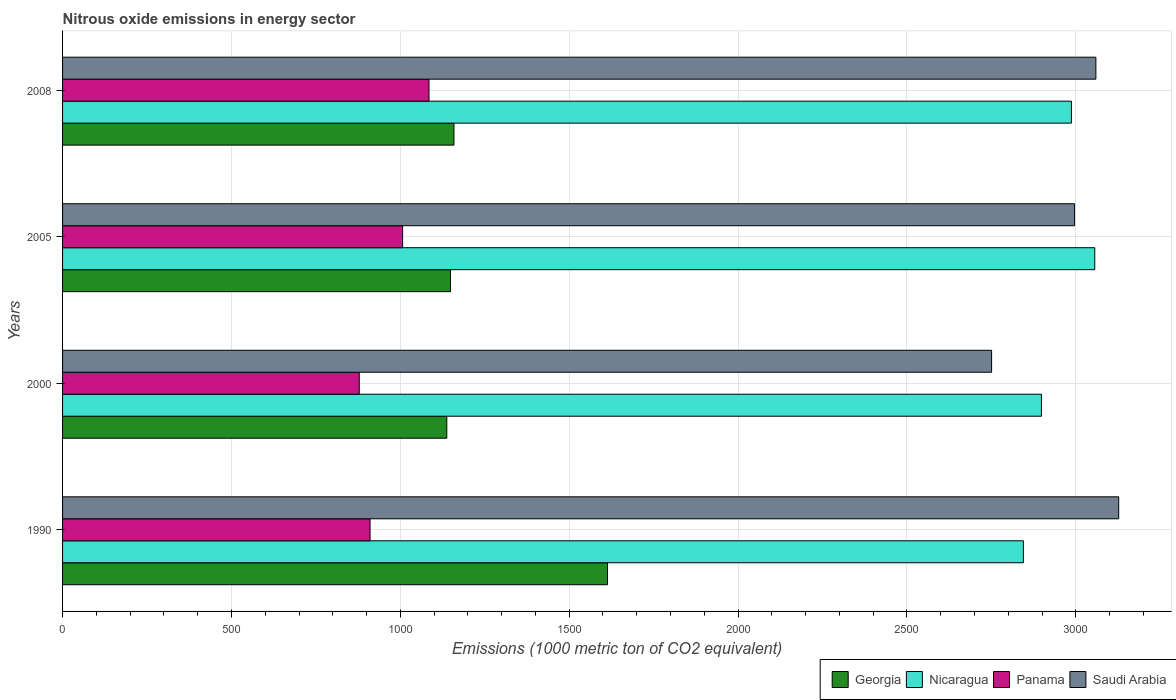How many groups of bars are there?
Provide a succinct answer. 4. Are the number of bars per tick equal to the number of legend labels?
Provide a short and direct response. Yes. What is the amount of nitrous oxide emitted in Panama in 2008?
Ensure brevity in your answer.  1084.9. Across all years, what is the maximum amount of nitrous oxide emitted in Nicaragua?
Ensure brevity in your answer.  3056.1. Across all years, what is the minimum amount of nitrous oxide emitted in Panama?
Your answer should be very brief. 878.4. In which year was the amount of nitrous oxide emitted in Panama minimum?
Keep it short and to the point. 2000. What is the total amount of nitrous oxide emitted in Nicaragua in the graph?
Offer a very short reply. 1.18e+04. What is the difference between the amount of nitrous oxide emitted in Saudi Arabia in 1990 and that in 2008?
Ensure brevity in your answer.  67.5. What is the difference between the amount of nitrous oxide emitted in Panama in 2000 and the amount of nitrous oxide emitted in Nicaragua in 2008?
Provide a succinct answer. -2108.5. What is the average amount of nitrous oxide emitted in Nicaragua per year?
Provide a succinct answer. 2946.47. In the year 2000, what is the difference between the amount of nitrous oxide emitted in Saudi Arabia and amount of nitrous oxide emitted in Georgia?
Keep it short and to the point. 1613. What is the ratio of the amount of nitrous oxide emitted in Saudi Arabia in 2000 to that in 2005?
Your answer should be compact. 0.92. What is the difference between the highest and the second highest amount of nitrous oxide emitted in Georgia?
Ensure brevity in your answer.  454.6. What is the difference between the highest and the lowest amount of nitrous oxide emitted in Nicaragua?
Make the answer very short. 211.4. Is the sum of the amount of nitrous oxide emitted in Nicaragua in 2000 and 2005 greater than the maximum amount of nitrous oxide emitted in Georgia across all years?
Your response must be concise. Yes. Is it the case that in every year, the sum of the amount of nitrous oxide emitted in Nicaragua and amount of nitrous oxide emitted in Saudi Arabia is greater than the sum of amount of nitrous oxide emitted in Panama and amount of nitrous oxide emitted in Georgia?
Provide a succinct answer. Yes. What does the 2nd bar from the top in 1990 represents?
Provide a succinct answer. Panama. What does the 3rd bar from the bottom in 1990 represents?
Your answer should be compact. Panama. Are all the bars in the graph horizontal?
Provide a short and direct response. Yes. How many years are there in the graph?
Give a very brief answer. 4. Does the graph contain any zero values?
Offer a very short reply. No. Does the graph contain grids?
Give a very brief answer. Yes. Where does the legend appear in the graph?
Your answer should be very brief. Bottom right. How are the legend labels stacked?
Your answer should be very brief. Horizontal. What is the title of the graph?
Give a very brief answer. Nitrous oxide emissions in energy sector. Does "Ukraine" appear as one of the legend labels in the graph?
Provide a short and direct response. No. What is the label or title of the X-axis?
Ensure brevity in your answer.  Emissions (1000 metric ton of CO2 equivalent). What is the label or title of the Y-axis?
Make the answer very short. Years. What is the Emissions (1000 metric ton of CO2 equivalent) in Georgia in 1990?
Offer a terse response. 1613.4. What is the Emissions (1000 metric ton of CO2 equivalent) of Nicaragua in 1990?
Your answer should be very brief. 2844.7. What is the Emissions (1000 metric ton of CO2 equivalent) of Panama in 1990?
Your response must be concise. 910.4. What is the Emissions (1000 metric ton of CO2 equivalent) of Saudi Arabia in 1990?
Your answer should be very brief. 3126.9. What is the Emissions (1000 metric ton of CO2 equivalent) in Georgia in 2000?
Provide a succinct answer. 1137.6. What is the Emissions (1000 metric ton of CO2 equivalent) of Nicaragua in 2000?
Provide a short and direct response. 2898.2. What is the Emissions (1000 metric ton of CO2 equivalent) in Panama in 2000?
Offer a very short reply. 878.4. What is the Emissions (1000 metric ton of CO2 equivalent) of Saudi Arabia in 2000?
Ensure brevity in your answer.  2750.6. What is the Emissions (1000 metric ton of CO2 equivalent) of Georgia in 2005?
Make the answer very short. 1148.6. What is the Emissions (1000 metric ton of CO2 equivalent) of Nicaragua in 2005?
Offer a terse response. 3056.1. What is the Emissions (1000 metric ton of CO2 equivalent) in Panama in 2005?
Provide a succinct answer. 1006.8. What is the Emissions (1000 metric ton of CO2 equivalent) in Saudi Arabia in 2005?
Provide a succinct answer. 2996.3. What is the Emissions (1000 metric ton of CO2 equivalent) of Georgia in 2008?
Provide a short and direct response. 1158.8. What is the Emissions (1000 metric ton of CO2 equivalent) in Nicaragua in 2008?
Keep it short and to the point. 2986.9. What is the Emissions (1000 metric ton of CO2 equivalent) in Panama in 2008?
Ensure brevity in your answer.  1084.9. What is the Emissions (1000 metric ton of CO2 equivalent) of Saudi Arabia in 2008?
Offer a very short reply. 3059.4. Across all years, what is the maximum Emissions (1000 metric ton of CO2 equivalent) in Georgia?
Your response must be concise. 1613.4. Across all years, what is the maximum Emissions (1000 metric ton of CO2 equivalent) in Nicaragua?
Offer a very short reply. 3056.1. Across all years, what is the maximum Emissions (1000 metric ton of CO2 equivalent) of Panama?
Your response must be concise. 1084.9. Across all years, what is the maximum Emissions (1000 metric ton of CO2 equivalent) of Saudi Arabia?
Give a very brief answer. 3126.9. Across all years, what is the minimum Emissions (1000 metric ton of CO2 equivalent) of Georgia?
Your answer should be very brief. 1137.6. Across all years, what is the minimum Emissions (1000 metric ton of CO2 equivalent) in Nicaragua?
Offer a very short reply. 2844.7. Across all years, what is the minimum Emissions (1000 metric ton of CO2 equivalent) of Panama?
Offer a terse response. 878.4. Across all years, what is the minimum Emissions (1000 metric ton of CO2 equivalent) of Saudi Arabia?
Your answer should be compact. 2750.6. What is the total Emissions (1000 metric ton of CO2 equivalent) of Georgia in the graph?
Offer a very short reply. 5058.4. What is the total Emissions (1000 metric ton of CO2 equivalent) of Nicaragua in the graph?
Provide a short and direct response. 1.18e+04. What is the total Emissions (1000 metric ton of CO2 equivalent) of Panama in the graph?
Keep it short and to the point. 3880.5. What is the total Emissions (1000 metric ton of CO2 equivalent) of Saudi Arabia in the graph?
Give a very brief answer. 1.19e+04. What is the difference between the Emissions (1000 metric ton of CO2 equivalent) in Georgia in 1990 and that in 2000?
Your answer should be very brief. 475.8. What is the difference between the Emissions (1000 metric ton of CO2 equivalent) in Nicaragua in 1990 and that in 2000?
Keep it short and to the point. -53.5. What is the difference between the Emissions (1000 metric ton of CO2 equivalent) of Panama in 1990 and that in 2000?
Keep it short and to the point. 32. What is the difference between the Emissions (1000 metric ton of CO2 equivalent) in Saudi Arabia in 1990 and that in 2000?
Offer a very short reply. 376.3. What is the difference between the Emissions (1000 metric ton of CO2 equivalent) of Georgia in 1990 and that in 2005?
Keep it short and to the point. 464.8. What is the difference between the Emissions (1000 metric ton of CO2 equivalent) in Nicaragua in 1990 and that in 2005?
Provide a short and direct response. -211.4. What is the difference between the Emissions (1000 metric ton of CO2 equivalent) of Panama in 1990 and that in 2005?
Your answer should be compact. -96.4. What is the difference between the Emissions (1000 metric ton of CO2 equivalent) in Saudi Arabia in 1990 and that in 2005?
Make the answer very short. 130.6. What is the difference between the Emissions (1000 metric ton of CO2 equivalent) in Georgia in 1990 and that in 2008?
Provide a succinct answer. 454.6. What is the difference between the Emissions (1000 metric ton of CO2 equivalent) of Nicaragua in 1990 and that in 2008?
Ensure brevity in your answer.  -142.2. What is the difference between the Emissions (1000 metric ton of CO2 equivalent) in Panama in 1990 and that in 2008?
Your answer should be compact. -174.5. What is the difference between the Emissions (1000 metric ton of CO2 equivalent) of Saudi Arabia in 1990 and that in 2008?
Make the answer very short. 67.5. What is the difference between the Emissions (1000 metric ton of CO2 equivalent) of Georgia in 2000 and that in 2005?
Give a very brief answer. -11. What is the difference between the Emissions (1000 metric ton of CO2 equivalent) in Nicaragua in 2000 and that in 2005?
Provide a short and direct response. -157.9. What is the difference between the Emissions (1000 metric ton of CO2 equivalent) of Panama in 2000 and that in 2005?
Provide a short and direct response. -128.4. What is the difference between the Emissions (1000 metric ton of CO2 equivalent) of Saudi Arabia in 2000 and that in 2005?
Your answer should be compact. -245.7. What is the difference between the Emissions (1000 metric ton of CO2 equivalent) of Georgia in 2000 and that in 2008?
Give a very brief answer. -21.2. What is the difference between the Emissions (1000 metric ton of CO2 equivalent) of Nicaragua in 2000 and that in 2008?
Give a very brief answer. -88.7. What is the difference between the Emissions (1000 metric ton of CO2 equivalent) in Panama in 2000 and that in 2008?
Provide a succinct answer. -206.5. What is the difference between the Emissions (1000 metric ton of CO2 equivalent) in Saudi Arabia in 2000 and that in 2008?
Ensure brevity in your answer.  -308.8. What is the difference between the Emissions (1000 metric ton of CO2 equivalent) in Georgia in 2005 and that in 2008?
Offer a terse response. -10.2. What is the difference between the Emissions (1000 metric ton of CO2 equivalent) of Nicaragua in 2005 and that in 2008?
Make the answer very short. 69.2. What is the difference between the Emissions (1000 metric ton of CO2 equivalent) of Panama in 2005 and that in 2008?
Your response must be concise. -78.1. What is the difference between the Emissions (1000 metric ton of CO2 equivalent) of Saudi Arabia in 2005 and that in 2008?
Your answer should be very brief. -63.1. What is the difference between the Emissions (1000 metric ton of CO2 equivalent) in Georgia in 1990 and the Emissions (1000 metric ton of CO2 equivalent) in Nicaragua in 2000?
Make the answer very short. -1284.8. What is the difference between the Emissions (1000 metric ton of CO2 equivalent) of Georgia in 1990 and the Emissions (1000 metric ton of CO2 equivalent) of Panama in 2000?
Provide a short and direct response. 735. What is the difference between the Emissions (1000 metric ton of CO2 equivalent) in Georgia in 1990 and the Emissions (1000 metric ton of CO2 equivalent) in Saudi Arabia in 2000?
Make the answer very short. -1137.2. What is the difference between the Emissions (1000 metric ton of CO2 equivalent) of Nicaragua in 1990 and the Emissions (1000 metric ton of CO2 equivalent) of Panama in 2000?
Your response must be concise. 1966.3. What is the difference between the Emissions (1000 metric ton of CO2 equivalent) in Nicaragua in 1990 and the Emissions (1000 metric ton of CO2 equivalent) in Saudi Arabia in 2000?
Provide a short and direct response. 94.1. What is the difference between the Emissions (1000 metric ton of CO2 equivalent) of Panama in 1990 and the Emissions (1000 metric ton of CO2 equivalent) of Saudi Arabia in 2000?
Provide a short and direct response. -1840.2. What is the difference between the Emissions (1000 metric ton of CO2 equivalent) in Georgia in 1990 and the Emissions (1000 metric ton of CO2 equivalent) in Nicaragua in 2005?
Give a very brief answer. -1442.7. What is the difference between the Emissions (1000 metric ton of CO2 equivalent) in Georgia in 1990 and the Emissions (1000 metric ton of CO2 equivalent) in Panama in 2005?
Give a very brief answer. 606.6. What is the difference between the Emissions (1000 metric ton of CO2 equivalent) in Georgia in 1990 and the Emissions (1000 metric ton of CO2 equivalent) in Saudi Arabia in 2005?
Offer a very short reply. -1382.9. What is the difference between the Emissions (1000 metric ton of CO2 equivalent) in Nicaragua in 1990 and the Emissions (1000 metric ton of CO2 equivalent) in Panama in 2005?
Your answer should be compact. 1837.9. What is the difference between the Emissions (1000 metric ton of CO2 equivalent) in Nicaragua in 1990 and the Emissions (1000 metric ton of CO2 equivalent) in Saudi Arabia in 2005?
Give a very brief answer. -151.6. What is the difference between the Emissions (1000 metric ton of CO2 equivalent) in Panama in 1990 and the Emissions (1000 metric ton of CO2 equivalent) in Saudi Arabia in 2005?
Offer a very short reply. -2085.9. What is the difference between the Emissions (1000 metric ton of CO2 equivalent) in Georgia in 1990 and the Emissions (1000 metric ton of CO2 equivalent) in Nicaragua in 2008?
Provide a short and direct response. -1373.5. What is the difference between the Emissions (1000 metric ton of CO2 equivalent) of Georgia in 1990 and the Emissions (1000 metric ton of CO2 equivalent) of Panama in 2008?
Ensure brevity in your answer.  528.5. What is the difference between the Emissions (1000 metric ton of CO2 equivalent) of Georgia in 1990 and the Emissions (1000 metric ton of CO2 equivalent) of Saudi Arabia in 2008?
Offer a very short reply. -1446. What is the difference between the Emissions (1000 metric ton of CO2 equivalent) of Nicaragua in 1990 and the Emissions (1000 metric ton of CO2 equivalent) of Panama in 2008?
Offer a very short reply. 1759.8. What is the difference between the Emissions (1000 metric ton of CO2 equivalent) in Nicaragua in 1990 and the Emissions (1000 metric ton of CO2 equivalent) in Saudi Arabia in 2008?
Make the answer very short. -214.7. What is the difference between the Emissions (1000 metric ton of CO2 equivalent) of Panama in 1990 and the Emissions (1000 metric ton of CO2 equivalent) of Saudi Arabia in 2008?
Keep it short and to the point. -2149. What is the difference between the Emissions (1000 metric ton of CO2 equivalent) in Georgia in 2000 and the Emissions (1000 metric ton of CO2 equivalent) in Nicaragua in 2005?
Your answer should be very brief. -1918.5. What is the difference between the Emissions (1000 metric ton of CO2 equivalent) of Georgia in 2000 and the Emissions (1000 metric ton of CO2 equivalent) of Panama in 2005?
Your answer should be very brief. 130.8. What is the difference between the Emissions (1000 metric ton of CO2 equivalent) in Georgia in 2000 and the Emissions (1000 metric ton of CO2 equivalent) in Saudi Arabia in 2005?
Give a very brief answer. -1858.7. What is the difference between the Emissions (1000 metric ton of CO2 equivalent) in Nicaragua in 2000 and the Emissions (1000 metric ton of CO2 equivalent) in Panama in 2005?
Keep it short and to the point. 1891.4. What is the difference between the Emissions (1000 metric ton of CO2 equivalent) of Nicaragua in 2000 and the Emissions (1000 metric ton of CO2 equivalent) of Saudi Arabia in 2005?
Give a very brief answer. -98.1. What is the difference between the Emissions (1000 metric ton of CO2 equivalent) of Panama in 2000 and the Emissions (1000 metric ton of CO2 equivalent) of Saudi Arabia in 2005?
Make the answer very short. -2117.9. What is the difference between the Emissions (1000 metric ton of CO2 equivalent) of Georgia in 2000 and the Emissions (1000 metric ton of CO2 equivalent) of Nicaragua in 2008?
Provide a succinct answer. -1849.3. What is the difference between the Emissions (1000 metric ton of CO2 equivalent) of Georgia in 2000 and the Emissions (1000 metric ton of CO2 equivalent) of Panama in 2008?
Your answer should be compact. 52.7. What is the difference between the Emissions (1000 metric ton of CO2 equivalent) of Georgia in 2000 and the Emissions (1000 metric ton of CO2 equivalent) of Saudi Arabia in 2008?
Keep it short and to the point. -1921.8. What is the difference between the Emissions (1000 metric ton of CO2 equivalent) of Nicaragua in 2000 and the Emissions (1000 metric ton of CO2 equivalent) of Panama in 2008?
Keep it short and to the point. 1813.3. What is the difference between the Emissions (1000 metric ton of CO2 equivalent) in Nicaragua in 2000 and the Emissions (1000 metric ton of CO2 equivalent) in Saudi Arabia in 2008?
Give a very brief answer. -161.2. What is the difference between the Emissions (1000 metric ton of CO2 equivalent) of Panama in 2000 and the Emissions (1000 metric ton of CO2 equivalent) of Saudi Arabia in 2008?
Provide a succinct answer. -2181. What is the difference between the Emissions (1000 metric ton of CO2 equivalent) in Georgia in 2005 and the Emissions (1000 metric ton of CO2 equivalent) in Nicaragua in 2008?
Provide a succinct answer. -1838.3. What is the difference between the Emissions (1000 metric ton of CO2 equivalent) in Georgia in 2005 and the Emissions (1000 metric ton of CO2 equivalent) in Panama in 2008?
Give a very brief answer. 63.7. What is the difference between the Emissions (1000 metric ton of CO2 equivalent) in Georgia in 2005 and the Emissions (1000 metric ton of CO2 equivalent) in Saudi Arabia in 2008?
Ensure brevity in your answer.  -1910.8. What is the difference between the Emissions (1000 metric ton of CO2 equivalent) in Nicaragua in 2005 and the Emissions (1000 metric ton of CO2 equivalent) in Panama in 2008?
Ensure brevity in your answer.  1971.2. What is the difference between the Emissions (1000 metric ton of CO2 equivalent) of Nicaragua in 2005 and the Emissions (1000 metric ton of CO2 equivalent) of Saudi Arabia in 2008?
Your response must be concise. -3.3. What is the difference between the Emissions (1000 metric ton of CO2 equivalent) in Panama in 2005 and the Emissions (1000 metric ton of CO2 equivalent) in Saudi Arabia in 2008?
Provide a short and direct response. -2052.6. What is the average Emissions (1000 metric ton of CO2 equivalent) of Georgia per year?
Offer a terse response. 1264.6. What is the average Emissions (1000 metric ton of CO2 equivalent) in Nicaragua per year?
Keep it short and to the point. 2946.47. What is the average Emissions (1000 metric ton of CO2 equivalent) in Panama per year?
Provide a short and direct response. 970.12. What is the average Emissions (1000 metric ton of CO2 equivalent) in Saudi Arabia per year?
Provide a short and direct response. 2983.3. In the year 1990, what is the difference between the Emissions (1000 metric ton of CO2 equivalent) in Georgia and Emissions (1000 metric ton of CO2 equivalent) in Nicaragua?
Keep it short and to the point. -1231.3. In the year 1990, what is the difference between the Emissions (1000 metric ton of CO2 equivalent) of Georgia and Emissions (1000 metric ton of CO2 equivalent) of Panama?
Offer a very short reply. 703. In the year 1990, what is the difference between the Emissions (1000 metric ton of CO2 equivalent) in Georgia and Emissions (1000 metric ton of CO2 equivalent) in Saudi Arabia?
Offer a terse response. -1513.5. In the year 1990, what is the difference between the Emissions (1000 metric ton of CO2 equivalent) of Nicaragua and Emissions (1000 metric ton of CO2 equivalent) of Panama?
Keep it short and to the point. 1934.3. In the year 1990, what is the difference between the Emissions (1000 metric ton of CO2 equivalent) in Nicaragua and Emissions (1000 metric ton of CO2 equivalent) in Saudi Arabia?
Your answer should be very brief. -282.2. In the year 1990, what is the difference between the Emissions (1000 metric ton of CO2 equivalent) of Panama and Emissions (1000 metric ton of CO2 equivalent) of Saudi Arabia?
Provide a short and direct response. -2216.5. In the year 2000, what is the difference between the Emissions (1000 metric ton of CO2 equivalent) of Georgia and Emissions (1000 metric ton of CO2 equivalent) of Nicaragua?
Your answer should be compact. -1760.6. In the year 2000, what is the difference between the Emissions (1000 metric ton of CO2 equivalent) in Georgia and Emissions (1000 metric ton of CO2 equivalent) in Panama?
Your answer should be very brief. 259.2. In the year 2000, what is the difference between the Emissions (1000 metric ton of CO2 equivalent) in Georgia and Emissions (1000 metric ton of CO2 equivalent) in Saudi Arabia?
Provide a succinct answer. -1613. In the year 2000, what is the difference between the Emissions (1000 metric ton of CO2 equivalent) in Nicaragua and Emissions (1000 metric ton of CO2 equivalent) in Panama?
Offer a very short reply. 2019.8. In the year 2000, what is the difference between the Emissions (1000 metric ton of CO2 equivalent) in Nicaragua and Emissions (1000 metric ton of CO2 equivalent) in Saudi Arabia?
Offer a terse response. 147.6. In the year 2000, what is the difference between the Emissions (1000 metric ton of CO2 equivalent) in Panama and Emissions (1000 metric ton of CO2 equivalent) in Saudi Arabia?
Keep it short and to the point. -1872.2. In the year 2005, what is the difference between the Emissions (1000 metric ton of CO2 equivalent) in Georgia and Emissions (1000 metric ton of CO2 equivalent) in Nicaragua?
Give a very brief answer. -1907.5. In the year 2005, what is the difference between the Emissions (1000 metric ton of CO2 equivalent) of Georgia and Emissions (1000 metric ton of CO2 equivalent) of Panama?
Provide a short and direct response. 141.8. In the year 2005, what is the difference between the Emissions (1000 metric ton of CO2 equivalent) of Georgia and Emissions (1000 metric ton of CO2 equivalent) of Saudi Arabia?
Offer a terse response. -1847.7. In the year 2005, what is the difference between the Emissions (1000 metric ton of CO2 equivalent) in Nicaragua and Emissions (1000 metric ton of CO2 equivalent) in Panama?
Give a very brief answer. 2049.3. In the year 2005, what is the difference between the Emissions (1000 metric ton of CO2 equivalent) in Nicaragua and Emissions (1000 metric ton of CO2 equivalent) in Saudi Arabia?
Your answer should be compact. 59.8. In the year 2005, what is the difference between the Emissions (1000 metric ton of CO2 equivalent) in Panama and Emissions (1000 metric ton of CO2 equivalent) in Saudi Arabia?
Offer a very short reply. -1989.5. In the year 2008, what is the difference between the Emissions (1000 metric ton of CO2 equivalent) of Georgia and Emissions (1000 metric ton of CO2 equivalent) of Nicaragua?
Offer a terse response. -1828.1. In the year 2008, what is the difference between the Emissions (1000 metric ton of CO2 equivalent) in Georgia and Emissions (1000 metric ton of CO2 equivalent) in Panama?
Provide a succinct answer. 73.9. In the year 2008, what is the difference between the Emissions (1000 metric ton of CO2 equivalent) in Georgia and Emissions (1000 metric ton of CO2 equivalent) in Saudi Arabia?
Offer a terse response. -1900.6. In the year 2008, what is the difference between the Emissions (1000 metric ton of CO2 equivalent) of Nicaragua and Emissions (1000 metric ton of CO2 equivalent) of Panama?
Offer a very short reply. 1902. In the year 2008, what is the difference between the Emissions (1000 metric ton of CO2 equivalent) of Nicaragua and Emissions (1000 metric ton of CO2 equivalent) of Saudi Arabia?
Your answer should be very brief. -72.5. In the year 2008, what is the difference between the Emissions (1000 metric ton of CO2 equivalent) of Panama and Emissions (1000 metric ton of CO2 equivalent) of Saudi Arabia?
Provide a succinct answer. -1974.5. What is the ratio of the Emissions (1000 metric ton of CO2 equivalent) in Georgia in 1990 to that in 2000?
Give a very brief answer. 1.42. What is the ratio of the Emissions (1000 metric ton of CO2 equivalent) of Nicaragua in 1990 to that in 2000?
Your answer should be compact. 0.98. What is the ratio of the Emissions (1000 metric ton of CO2 equivalent) in Panama in 1990 to that in 2000?
Give a very brief answer. 1.04. What is the ratio of the Emissions (1000 metric ton of CO2 equivalent) in Saudi Arabia in 1990 to that in 2000?
Ensure brevity in your answer.  1.14. What is the ratio of the Emissions (1000 metric ton of CO2 equivalent) in Georgia in 1990 to that in 2005?
Provide a short and direct response. 1.4. What is the ratio of the Emissions (1000 metric ton of CO2 equivalent) in Nicaragua in 1990 to that in 2005?
Keep it short and to the point. 0.93. What is the ratio of the Emissions (1000 metric ton of CO2 equivalent) in Panama in 1990 to that in 2005?
Make the answer very short. 0.9. What is the ratio of the Emissions (1000 metric ton of CO2 equivalent) of Saudi Arabia in 1990 to that in 2005?
Keep it short and to the point. 1.04. What is the ratio of the Emissions (1000 metric ton of CO2 equivalent) in Georgia in 1990 to that in 2008?
Provide a succinct answer. 1.39. What is the ratio of the Emissions (1000 metric ton of CO2 equivalent) in Panama in 1990 to that in 2008?
Provide a short and direct response. 0.84. What is the ratio of the Emissions (1000 metric ton of CO2 equivalent) in Saudi Arabia in 1990 to that in 2008?
Provide a short and direct response. 1.02. What is the ratio of the Emissions (1000 metric ton of CO2 equivalent) of Georgia in 2000 to that in 2005?
Offer a very short reply. 0.99. What is the ratio of the Emissions (1000 metric ton of CO2 equivalent) in Nicaragua in 2000 to that in 2005?
Your answer should be compact. 0.95. What is the ratio of the Emissions (1000 metric ton of CO2 equivalent) of Panama in 2000 to that in 2005?
Ensure brevity in your answer.  0.87. What is the ratio of the Emissions (1000 metric ton of CO2 equivalent) of Saudi Arabia in 2000 to that in 2005?
Keep it short and to the point. 0.92. What is the ratio of the Emissions (1000 metric ton of CO2 equivalent) of Georgia in 2000 to that in 2008?
Your response must be concise. 0.98. What is the ratio of the Emissions (1000 metric ton of CO2 equivalent) in Nicaragua in 2000 to that in 2008?
Your answer should be compact. 0.97. What is the ratio of the Emissions (1000 metric ton of CO2 equivalent) in Panama in 2000 to that in 2008?
Your answer should be compact. 0.81. What is the ratio of the Emissions (1000 metric ton of CO2 equivalent) of Saudi Arabia in 2000 to that in 2008?
Give a very brief answer. 0.9. What is the ratio of the Emissions (1000 metric ton of CO2 equivalent) in Nicaragua in 2005 to that in 2008?
Your response must be concise. 1.02. What is the ratio of the Emissions (1000 metric ton of CO2 equivalent) in Panama in 2005 to that in 2008?
Offer a terse response. 0.93. What is the ratio of the Emissions (1000 metric ton of CO2 equivalent) of Saudi Arabia in 2005 to that in 2008?
Provide a succinct answer. 0.98. What is the difference between the highest and the second highest Emissions (1000 metric ton of CO2 equivalent) in Georgia?
Keep it short and to the point. 454.6. What is the difference between the highest and the second highest Emissions (1000 metric ton of CO2 equivalent) in Nicaragua?
Keep it short and to the point. 69.2. What is the difference between the highest and the second highest Emissions (1000 metric ton of CO2 equivalent) in Panama?
Ensure brevity in your answer.  78.1. What is the difference between the highest and the second highest Emissions (1000 metric ton of CO2 equivalent) in Saudi Arabia?
Make the answer very short. 67.5. What is the difference between the highest and the lowest Emissions (1000 metric ton of CO2 equivalent) of Georgia?
Your response must be concise. 475.8. What is the difference between the highest and the lowest Emissions (1000 metric ton of CO2 equivalent) in Nicaragua?
Provide a succinct answer. 211.4. What is the difference between the highest and the lowest Emissions (1000 metric ton of CO2 equivalent) in Panama?
Ensure brevity in your answer.  206.5. What is the difference between the highest and the lowest Emissions (1000 metric ton of CO2 equivalent) of Saudi Arabia?
Offer a terse response. 376.3. 